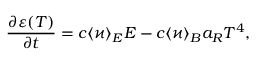Convert formula to latex. <formula><loc_0><loc_0><loc_500><loc_500>\frac { \partial \varepsilon ( T ) } { \partial t } = c \langle \varkappa \rangle _ { E } E - c \langle \varkappa \rangle _ { B } a _ { R } T ^ { 4 } ,</formula> 